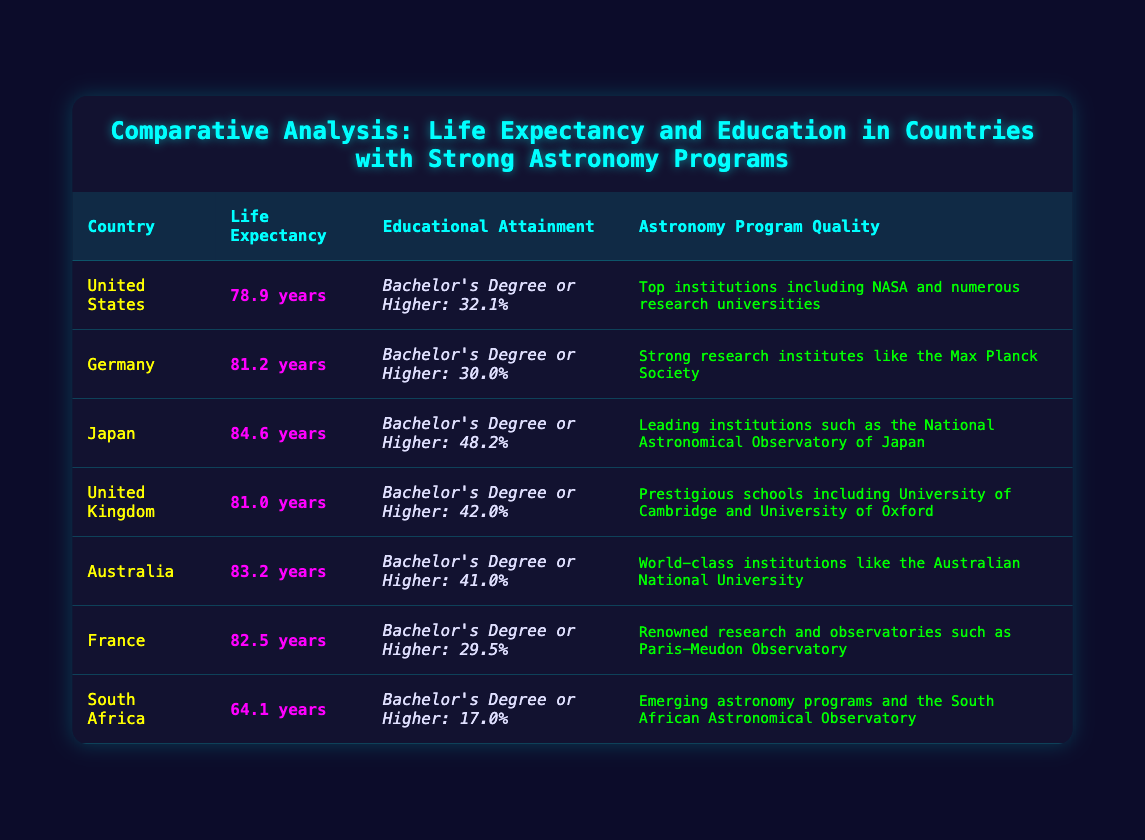What is the life expectancy of Japan? The table shows life expectancy data for various countries. Looking specifically at Japan, the life expectancy is listed as 84.6 years.
Answer: 84.6 years Which country has the highest educational attainment percentage? By comparing the educational attainment percentages in the table, Japan has the highest percentage at 48.2%, while the other countries have lower values.
Answer: Japan Is the life expectancy of South Africa greater than 70 years? The life expectancy of South Africa is explicitly stated in the table as 64.1 years, which is less than 70 years. Therefore, the answer is no.
Answer: No What is the average life expectancy of the countries listed? To find the average life expectancy: sum the life expectancies: (78.9 + 81.2 + 84.6 + 81.0 + 83.2 + 82.5 + 64.1) = 455.5. There are 7 countries, so the average is 455.5 / 7 = 65.07 (approx 65.07).
Answer: 65.07 years Which country has the lowest percentage of educational attainment? By inspecting the educational attainment percentages of each country, we see that South Africa has the lowest percentage at 17.0%.
Answer: South Africa Is there a country with both high life expectancy and high educational attainment? Japan has a high life expectancy of 84.6 years and the highest educational attainment percentage of 48.2%, suggesting that it fits the criteria of both high life expectancy and high educational attainment.
Answer: Yes Which countries have a life expectancy greater than 80 years? The countries with a life expectancy greater than 80 years are Germany (81.2), Japan (84.6), United Kingdom (81.0), and Australia (83.2). This involves filtering out countries whose life expectancy is 80 years or lower.
Answer: Germany, Japan, United Kingdom, Australia What is the difference in life expectancy between the United States and Japan? The life expectancy in the United States is 78.9 years and in Japan is 84.6 years. The difference is calculated as 84.6 - 78.9 = 5.7 years.
Answer: 5.7 years 